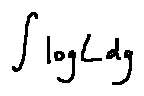Convert formula to latex. <formula><loc_0><loc_0><loc_500><loc_500>\int \log L d g</formula> 